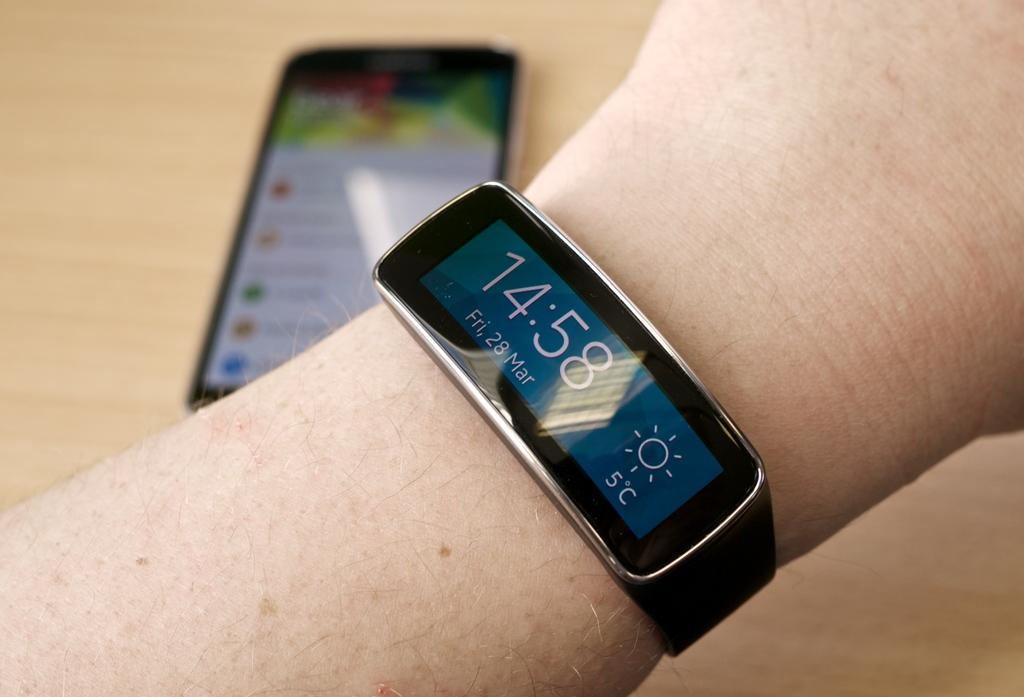<image>
Create a compact narrative representing the image presented. A person is wearing a watch that says the time is 14:58. 